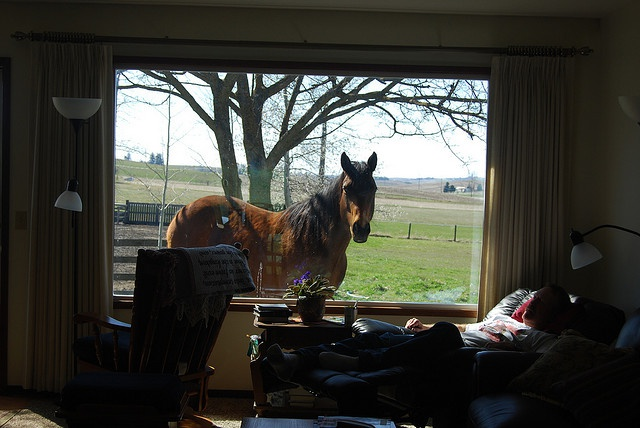Describe the objects in this image and their specific colors. I can see chair in black, gray, and darkblue tones, horse in black, maroon, and gray tones, people in black, white, darkgray, and gray tones, potted plant in black, darkgreen, and gray tones, and book in black, darkgray, gray, and lightgray tones in this image. 